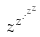Convert formula to latex. <formula><loc_0><loc_0><loc_500><loc_500>z ^ { z ^ { \cdot ^ { \cdot ^ { z ^ { z } } } } }</formula> 